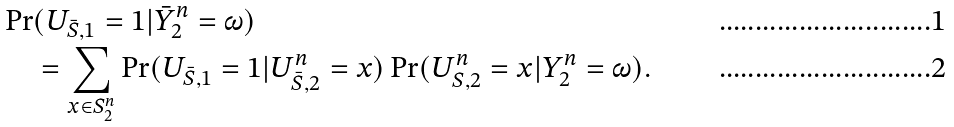<formula> <loc_0><loc_0><loc_500><loc_500>\Pr & ( U _ { \bar { S } , 1 } = 1 | { \bar { Y } } _ { 2 } ^ { n } = \omega ) \\ & = \sum _ { x \in S _ { 2 } ^ { n } } \Pr ( U _ { \bar { S } , 1 } = 1 | { U } _ { \bar { S } , 2 } ^ { n } = x ) \Pr ( U _ { S , 2 } ^ { n } = x | Y _ { 2 } ^ { n } = \omega ) .</formula> 